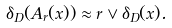Convert formula to latex. <formula><loc_0><loc_0><loc_500><loc_500>\delta _ { D } ( A _ { r } ( x ) ) \approx r \vee \delta _ { D } ( x ) .</formula> 